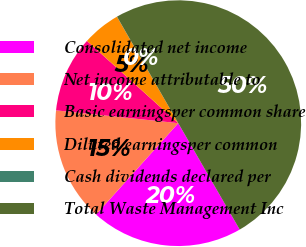<chart> <loc_0><loc_0><loc_500><loc_500><pie_chart><fcel>Consolidated net income<fcel>Net income attributable to<fcel>Basic earningsper common share<fcel>Diluted earningsper common<fcel>Cash dividends declared per<fcel>Total Waste Management Inc<nl><fcel>20.0%<fcel>15.0%<fcel>10.01%<fcel>5.01%<fcel>0.01%<fcel>49.97%<nl></chart> 